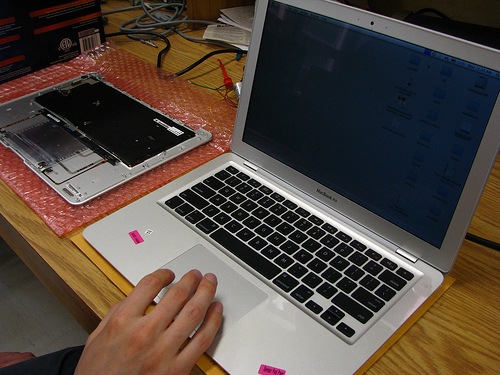<image>
Is the finger above the screen? No. The finger is not positioned above the screen. The vertical arrangement shows a different relationship. 